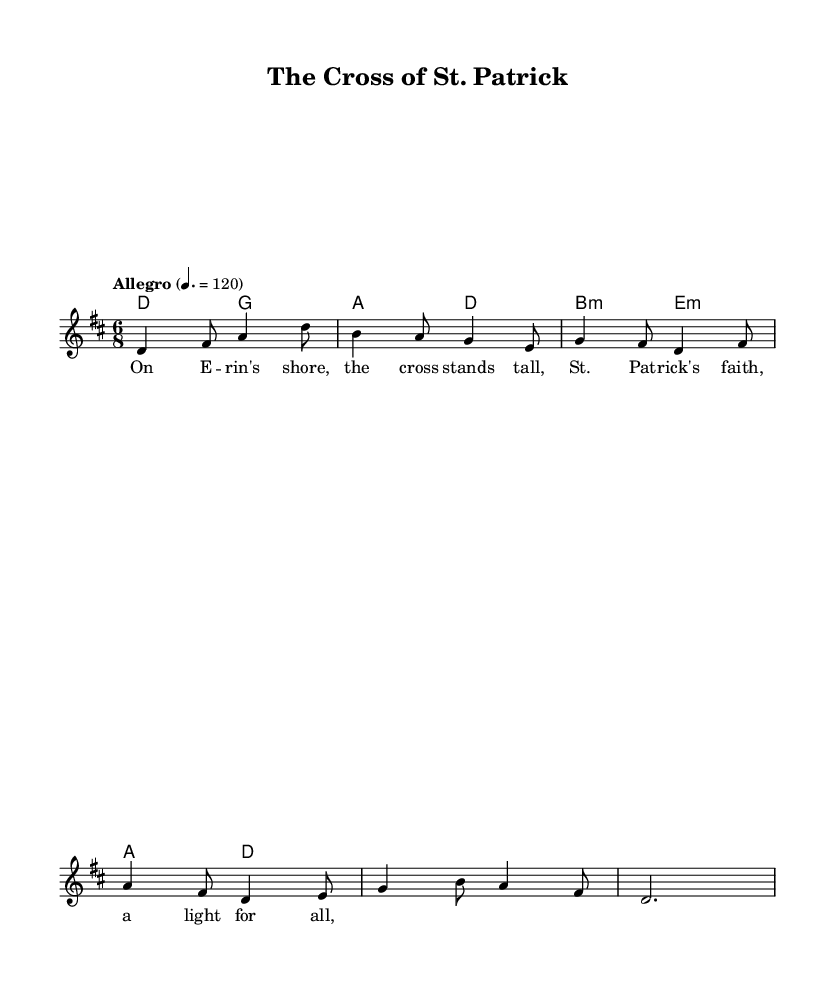What is the key signature of this music? The key signature is indicated at the beginning of the score. It shows two sharps, which corresponds to D major.
Answer: D major What is the time signature of the piece? The time signature appears at the beginning of the score and shows "6/8", indicating there are six eighth notes per measure.
Answer: 6/8 What is the tempo marking for this piece? The tempo marking is found in the score and states "Allegro" with a metronome marking of quarter note equals 120, indicating a brisk tempo.
Answer: Allegro, 120 How many measures are in the melody? By counting the measures in the melody section, the score contains a total of 5 measures displayed.
Answer: 5 What chords are used in the harmony section? The harmony section shows various chord symbols: D, G, A, B minor, and E minor; these are the chords played alongside the melody.
Answer: D, G, A, B minor, E minor What Christian theme is represented in the lyrics? The lyrics speak about "St. Patrick's faith" and "the cross," representing a strong Christian symbolism embedded in the context of the song.
Answer: St. Patrick's faith, the cross What is the phrase structure of the lyrics? Analyzing the lyrics reveals that they are structured in a straightforward AABA format, with each section contributing to the overall theme discussed.
Answer: AABA 